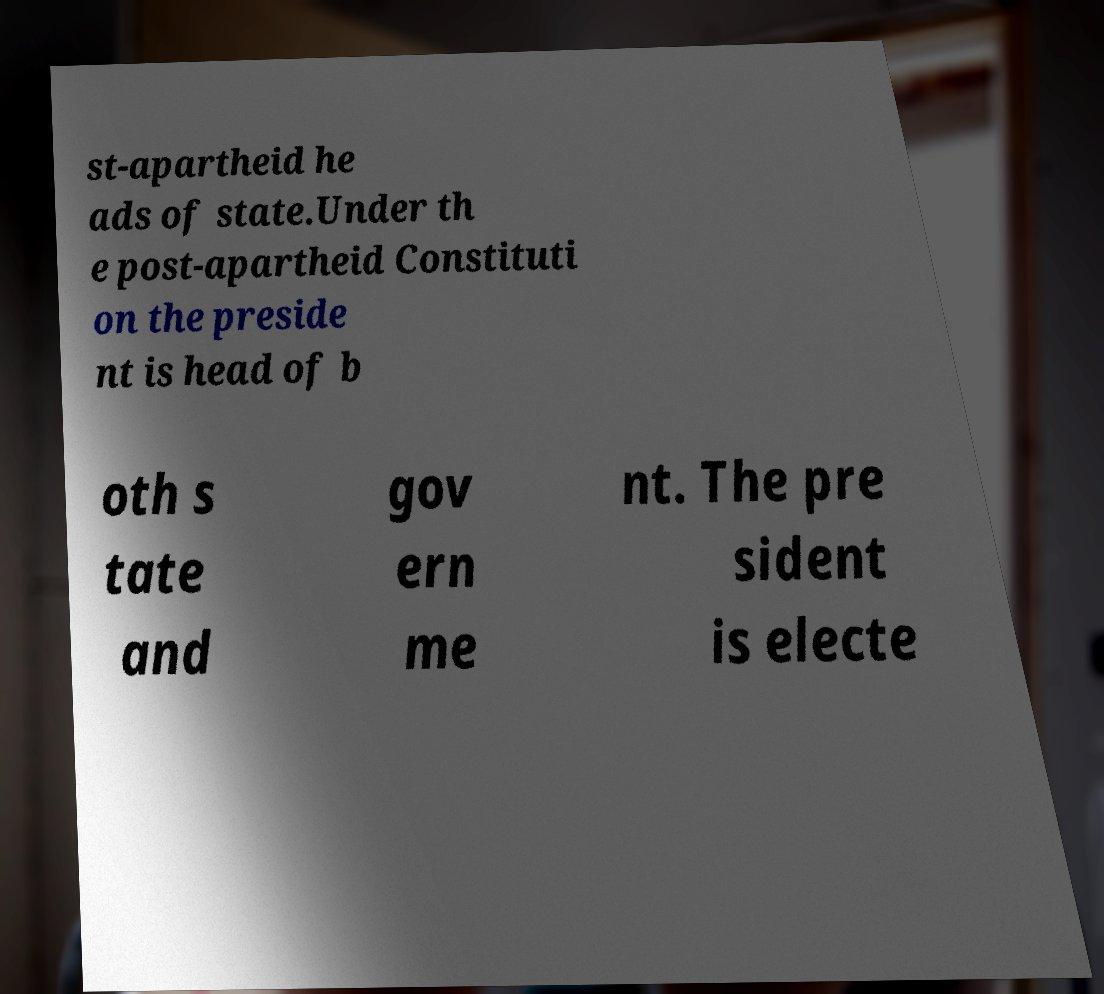Could you extract and type out the text from this image? st-apartheid he ads of state.Under th e post-apartheid Constituti on the preside nt is head of b oth s tate and gov ern me nt. The pre sident is electe 